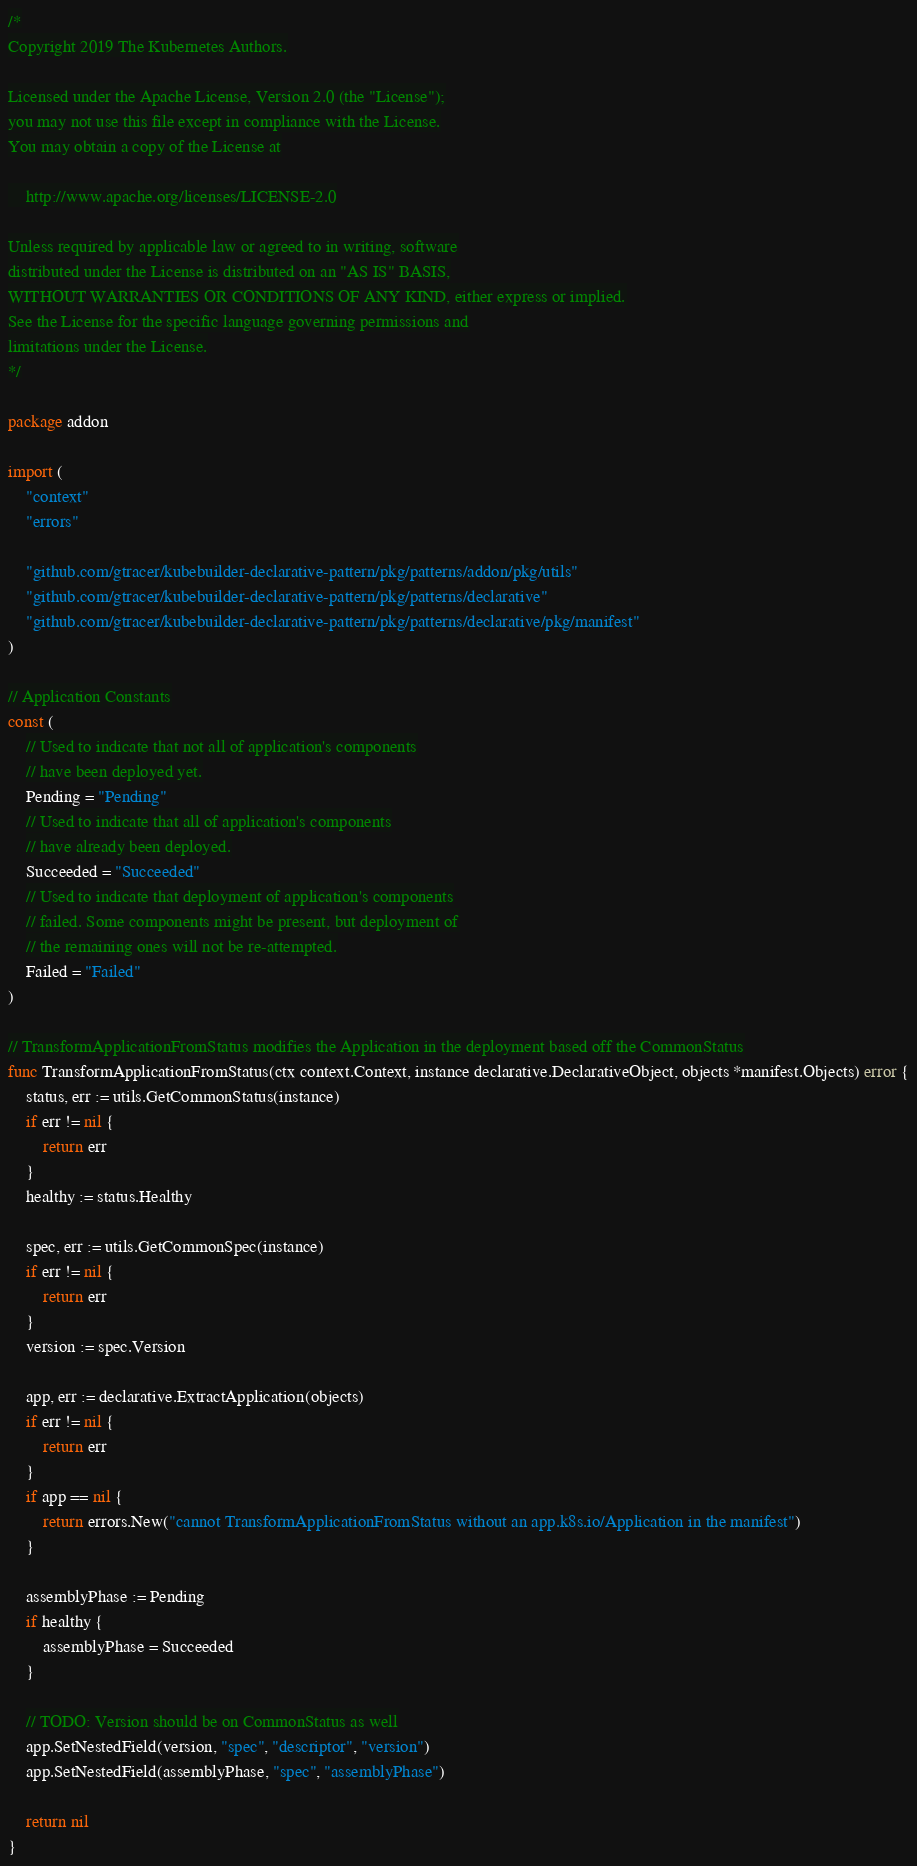Convert code to text. <code><loc_0><loc_0><loc_500><loc_500><_Go_>/*
Copyright 2019 The Kubernetes Authors.

Licensed under the Apache License, Version 2.0 (the "License");
you may not use this file except in compliance with the License.
You may obtain a copy of the License at

    http://www.apache.org/licenses/LICENSE-2.0

Unless required by applicable law or agreed to in writing, software
distributed under the License is distributed on an "AS IS" BASIS,
WITHOUT WARRANTIES OR CONDITIONS OF ANY KIND, either express or implied.
See the License for the specific language governing permissions and
limitations under the License.
*/

package addon

import (
	"context"
	"errors"

	"github.com/gtracer/kubebuilder-declarative-pattern/pkg/patterns/addon/pkg/utils"
	"github.com/gtracer/kubebuilder-declarative-pattern/pkg/patterns/declarative"
	"github.com/gtracer/kubebuilder-declarative-pattern/pkg/patterns/declarative/pkg/manifest"
)

// Application Constants
const (
	// Used to indicate that not all of application's components
	// have been deployed yet.
	Pending = "Pending"
	// Used to indicate that all of application's components
	// have already been deployed.
	Succeeded = "Succeeded"
	// Used to indicate that deployment of application's components
	// failed. Some components might be present, but deployment of
	// the remaining ones will not be re-attempted.
	Failed = "Failed"
)

// TransformApplicationFromStatus modifies the Application in the deployment based off the CommonStatus
func TransformApplicationFromStatus(ctx context.Context, instance declarative.DeclarativeObject, objects *manifest.Objects) error {
	status, err := utils.GetCommonStatus(instance)
	if err != nil {
		return err
	}
	healthy := status.Healthy

	spec, err := utils.GetCommonSpec(instance)
	if err != nil {
		return err
	}
	version := spec.Version

	app, err := declarative.ExtractApplication(objects)
	if err != nil {
		return err
	}
	if app == nil {
		return errors.New("cannot TransformApplicationFromStatus without an app.k8s.io/Application in the manifest")
	}

	assemblyPhase := Pending
	if healthy {
		assemblyPhase = Succeeded
	}

	// TODO: Version should be on CommonStatus as well
	app.SetNestedField(version, "spec", "descriptor", "version")
	app.SetNestedField(assemblyPhase, "spec", "assemblyPhase")

	return nil
}
</code> 